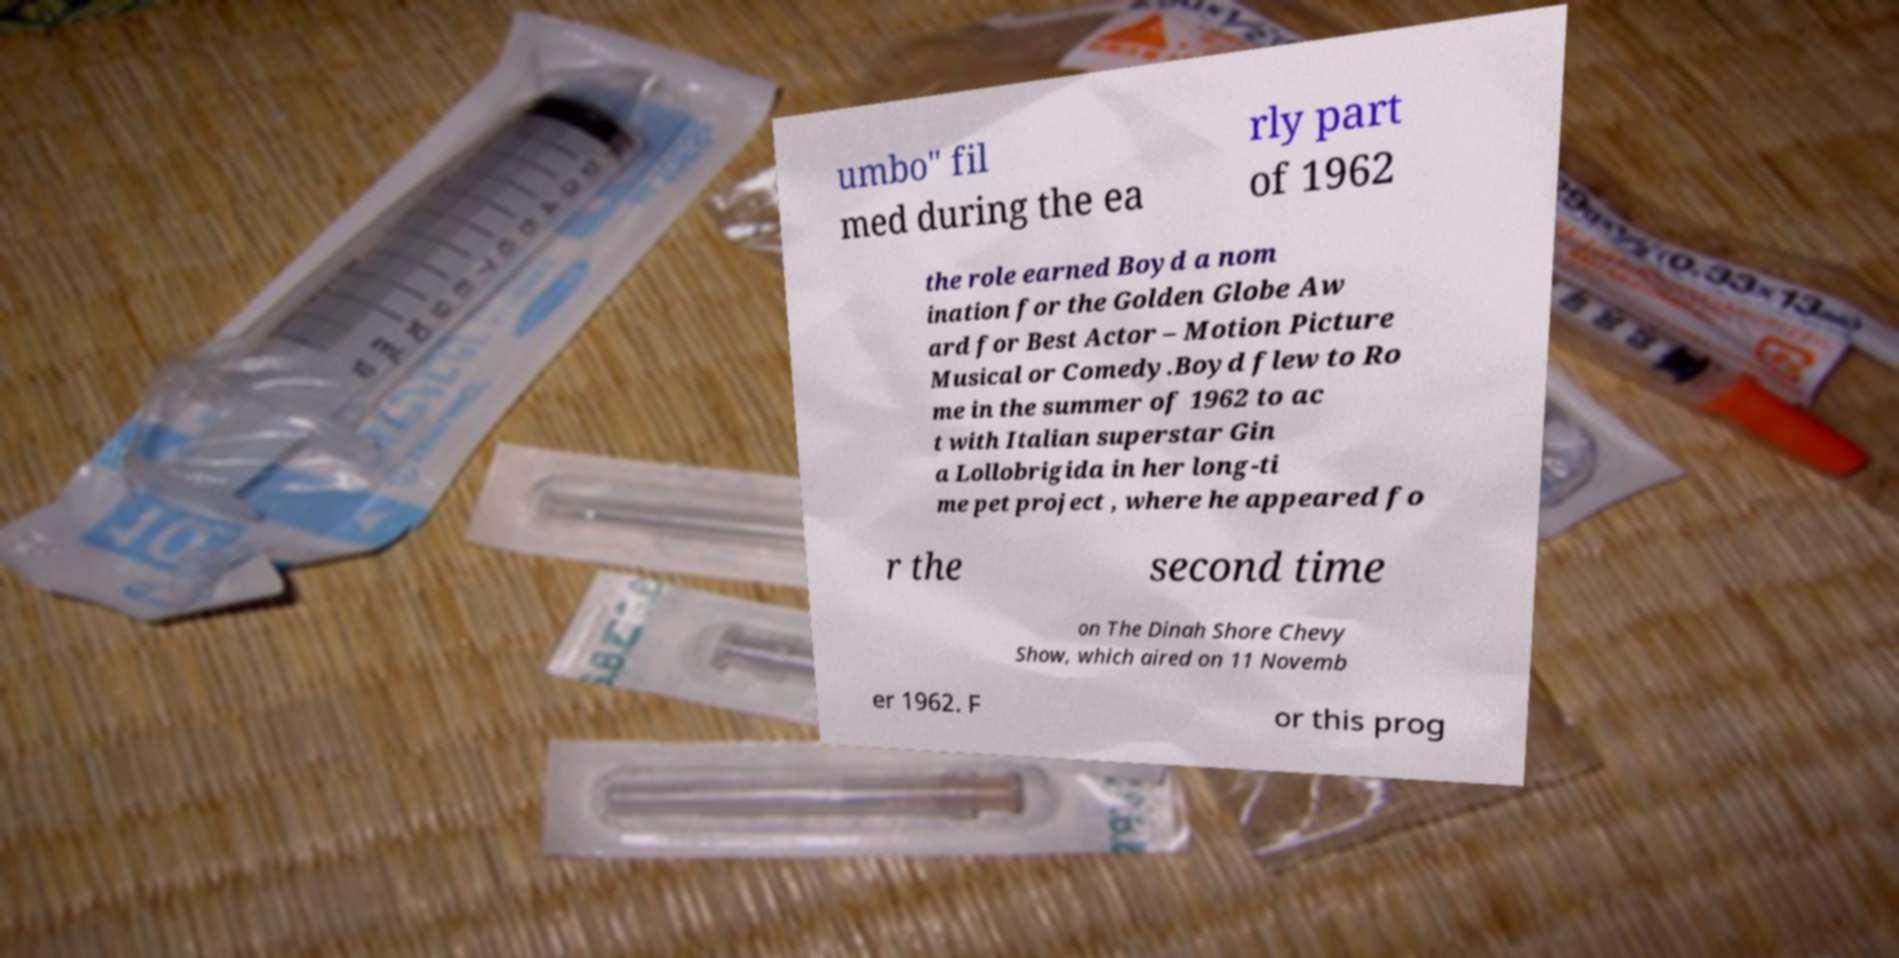Can you read and provide the text displayed in the image?This photo seems to have some interesting text. Can you extract and type it out for me? umbo" fil med during the ea rly part of 1962 the role earned Boyd a nom ination for the Golden Globe Aw ard for Best Actor – Motion Picture Musical or Comedy.Boyd flew to Ro me in the summer of 1962 to ac t with Italian superstar Gin a Lollobrigida in her long-ti me pet project , where he appeared fo r the second time on The Dinah Shore Chevy Show, which aired on 11 Novemb er 1962. F or this prog 